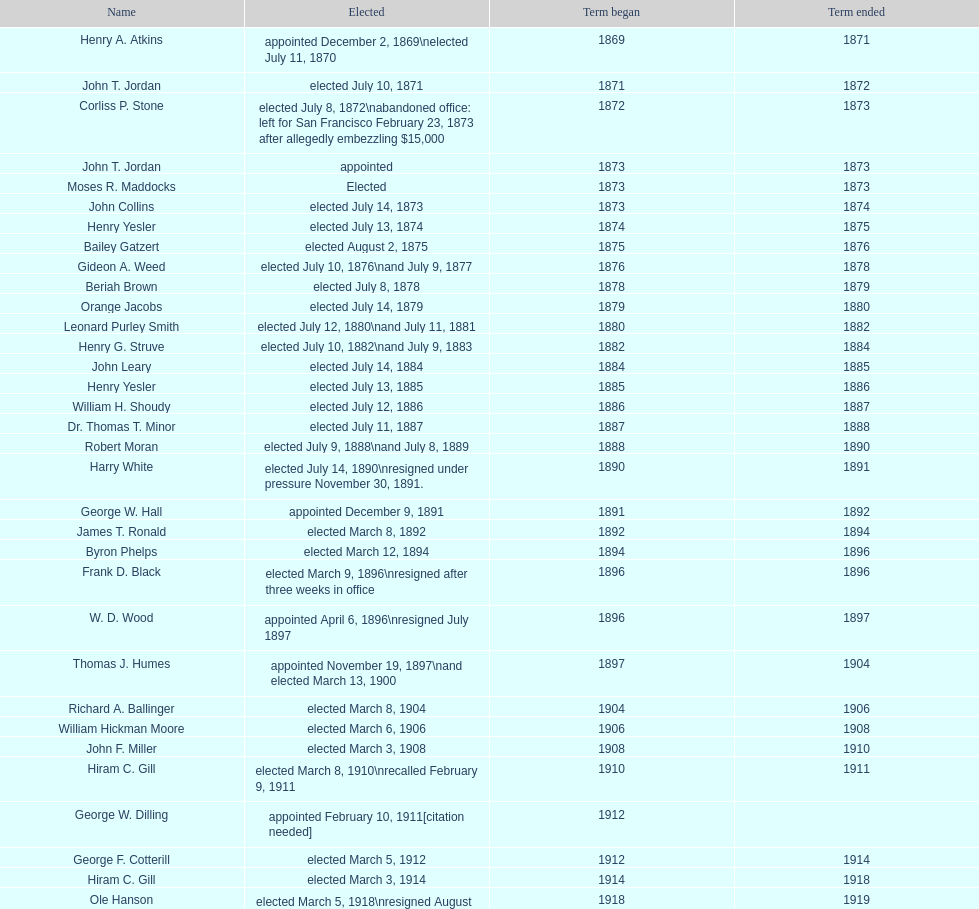Who was the only person elected in 1871? John T. Jordan. 